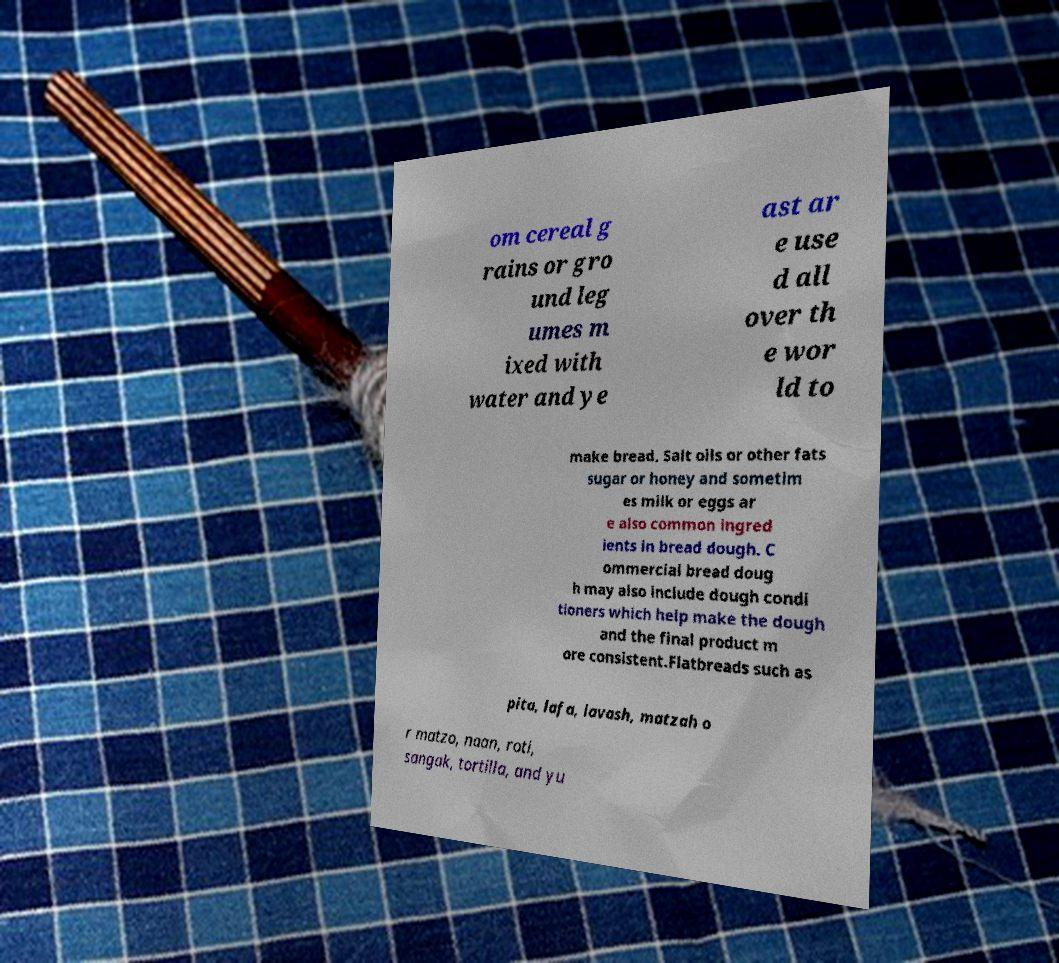Could you extract and type out the text from this image? om cereal g rains or gro und leg umes m ixed with water and ye ast ar e use d all over th e wor ld to make bread. Salt oils or other fats sugar or honey and sometim es milk or eggs ar e also common ingred ients in bread dough. C ommercial bread doug h may also include dough condi tioners which help make the dough and the final product m ore consistent.Flatbreads such as pita, lafa, lavash, matzah o r matzo, naan, roti, sangak, tortilla, and yu 